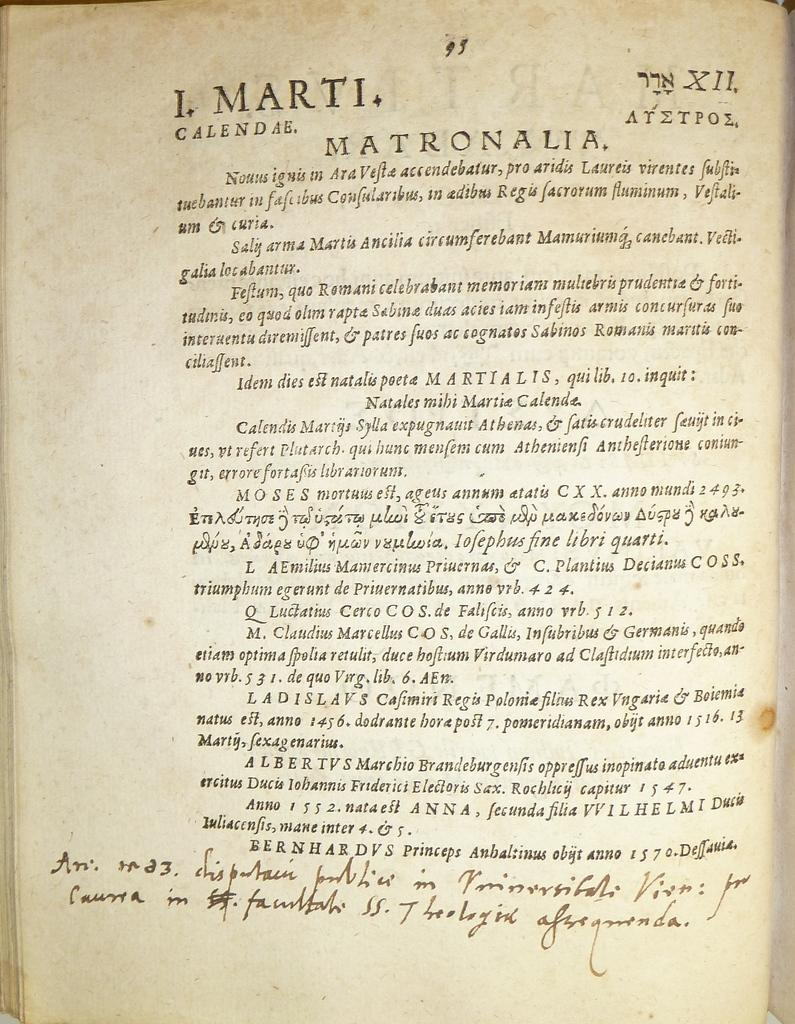<image>
Relay a brief, clear account of the picture shown. A page of text written in a foreign language is about Matronalia, and has some handwriting at the bottom. 